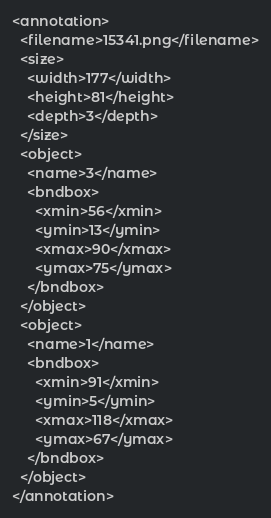<code> <loc_0><loc_0><loc_500><loc_500><_XML_><annotation>
  <filename>15341.png</filename>
  <size>
    <width>177</width>
    <height>81</height>
    <depth>3</depth>
  </size>
  <object>
    <name>3</name>
    <bndbox>
      <xmin>56</xmin>
      <ymin>13</ymin>
      <xmax>90</xmax>
      <ymax>75</ymax>
    </bndbox>
  </object>
  <object>
    <name>1</name>
    <bndbox>
      <xmin>91</xmin>
      <ymin>5</ymin>
      <xmax>118</xmax>
      <ymax>67</ymax>
    </bndbox>
  </object>
</annotation>
</code> 